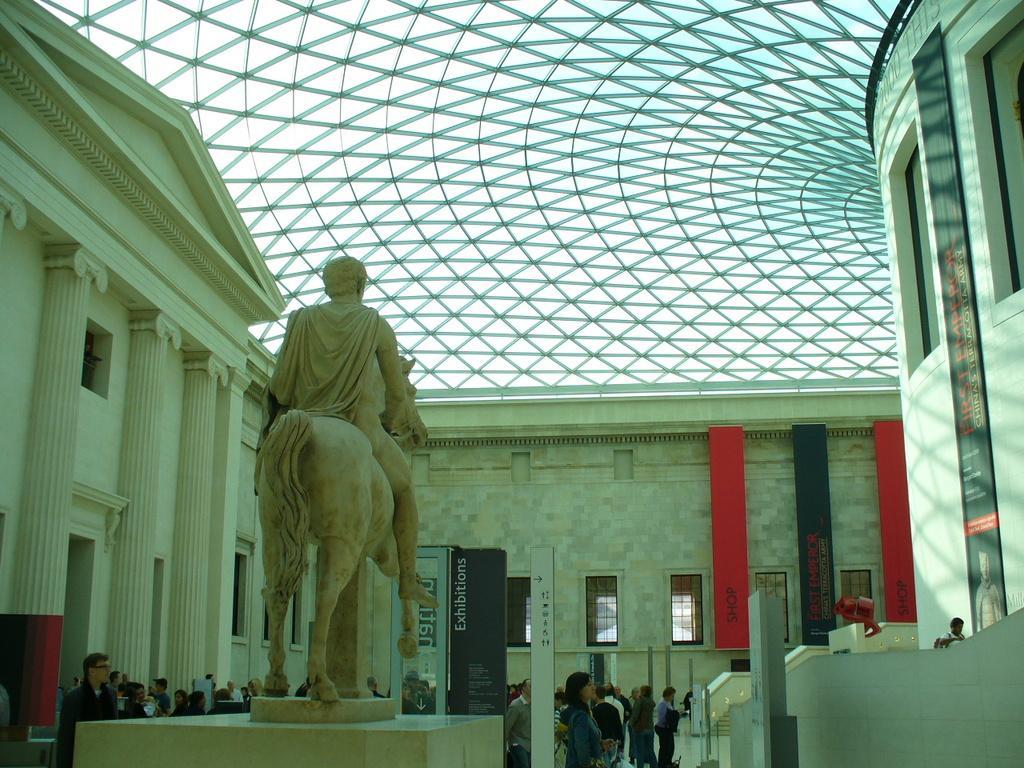How would you summarize this image in a sentence or two? In the foreground of the picture I can see the statue of a man sitting on the horse. In the background, I can see a group of people. I can see the building on the left side. There is a banner on the wall on the right side. 